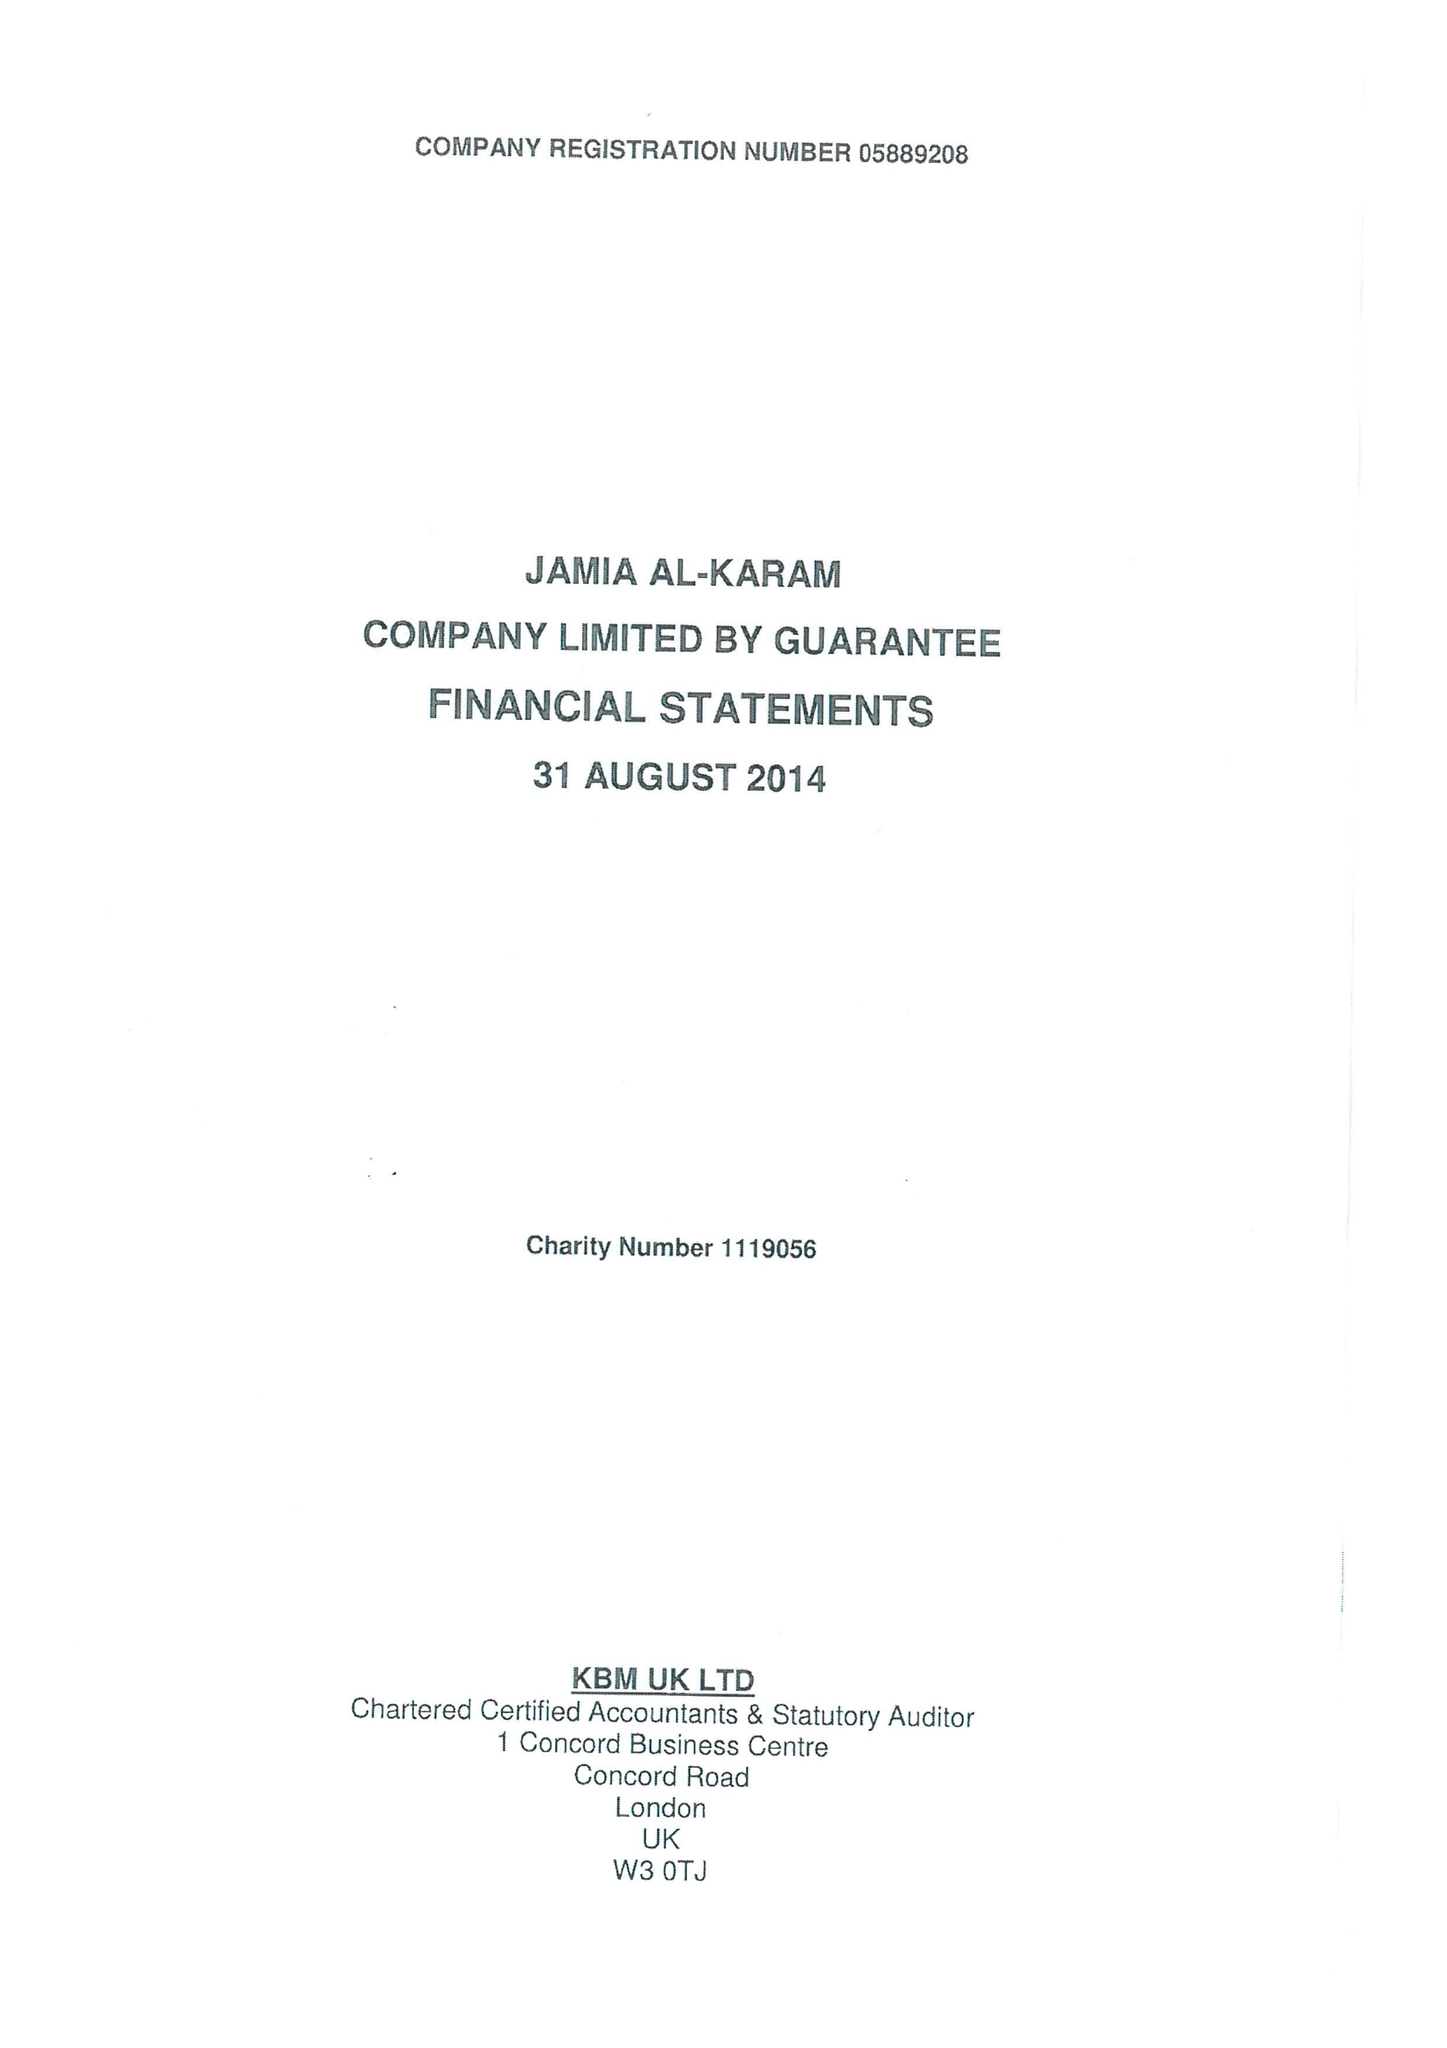What is the value for the spending_annually_in_british_pounds?
Answer the question using a single word or phrase. 762688.00 